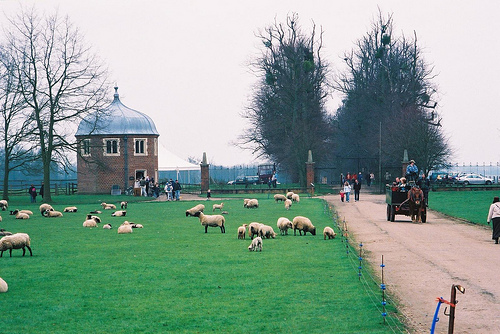Are there any people in the scene? Yes, there are a few people visible. On the road, there is a small group of people witnessing a carriage pulled by a pair of horses. The carriage driver and a helper are riding up front, while a few more people are in the carriage itself, enjoying the ride.  What is the activity in the image? The main activity appears to be a leisurely horse-drawn carriage ride. It looks like an organized event or a tourist attraction, allowing visitors to experience a traditional form of transportation. Meanwhile, the sheep are calmly grazing in the field, adding to the serene, bucolic atmosphere. 